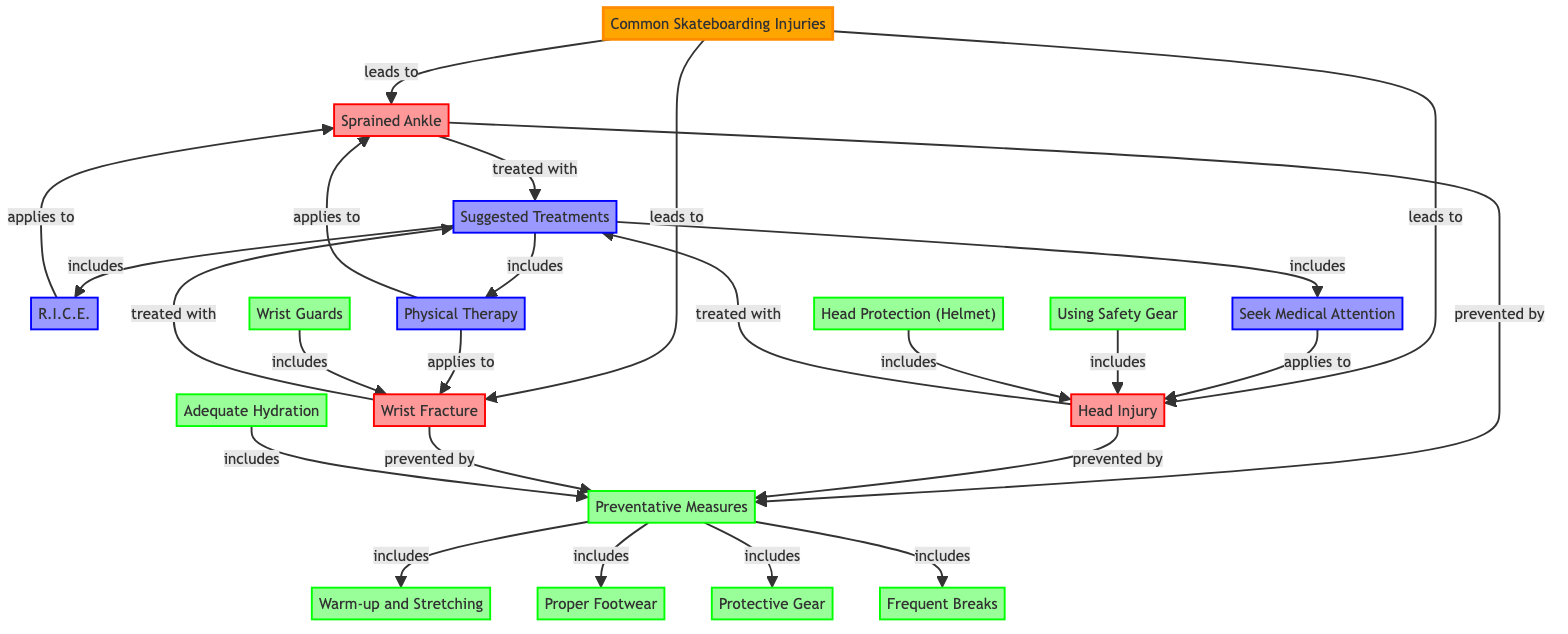What are the common skateboard injuries listed in the diagram? The diagram lists three common skateboard injuries: Sprained Ankle, Head Injury, and Wrist Fracture. These injuries are directly connected to the main node "Common Skateboarding Injuries."
Answer: Sprained Ankle, Head Injury, Wrist Fracture How many preventative measures are suggested in the diagram? The diagram includes a total of seven preventative measures: Warm-up and Stretching, Proper Footwear, Protective Gear, Frequent Breaks, Using Safety Gear, Head Protection (Helmet), and Wrist Guards. I counted each measure connected to the "Preventative Measures" node.
Answer: 7 Which treatment is suggested for wrist fractures? The diagram indicates that Physical Therapy is suggested for treating wrist fractures, as it's connected to the "Suggested Treatments" node for both Sprained Ankle and Wrist Fracture.
Answer: Physical Therapy What preventative measure is specifically related to hydration? The diagram includes Adequate Hydration under the "Preventative Measures" section, establishing it as a solution to maintain the health of skateboarders and prevent injuries.
Answer: Adequate Hydration What is the relationship between "Head Injury" and "Protective Gear"? The diagram shows that "Head Injury" can be prevented by "Preventative Measures," one of which is the use of "Protective Gear." This indicates they are connected through the flow of preventative strategies.
Answer: Prevented by What types of suggested treatments are listed in the diagram? The diagram delineates three suggested treatments: R.I.C.E., Seek Medical Attention, and Physical Therapy, categorized under the "Suggested Treatments" node related to the injuries.
Answer: R.I.C.E., Seek Medical Attention, Physical Therapy Which injury is associated with Head Protection? According to the diagram, Head Protection (Helmet) is particularly associated with preventing Head Injuries as it falls under the preventative measures directly connected to that injury.
Answer: Head Injury What is the connection between using safety gear and sprained ankles? The diagram illustrates that using safety gear is a preventative measure that can help reduce the risk of sprained ankles since both are linked through the "Preventative Measures" node and the injury itself.
Answer: Preventability 